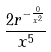Convert formula to latex. <formula><loc_0><loc_0><loc_500><loc_500>\frac { 2 r ^ { - \frac { 0 } { x ^ { 2 } } } } { x ^ { 5 } }</formula> 